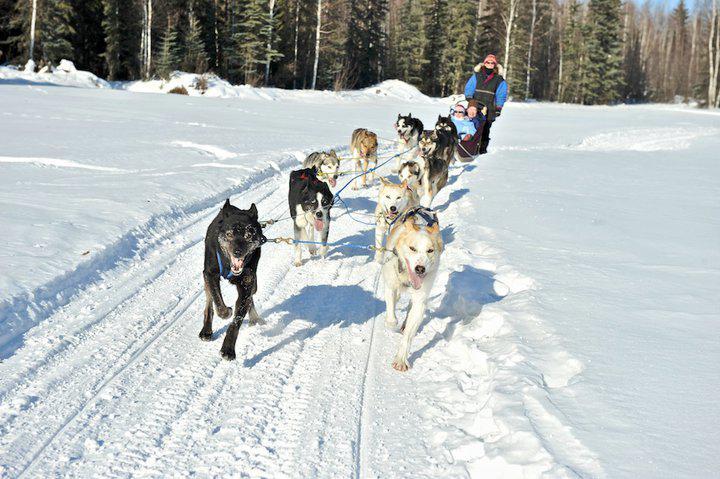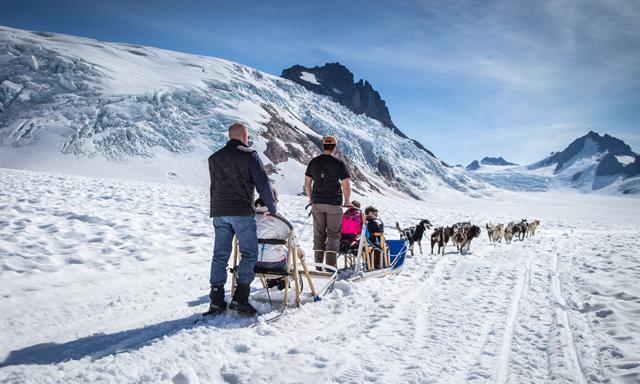The first image is the image on the left, the second image is the image on the right. Considering the images on both sides, is "In at least one image there is a person in blue in the sled and a person in red behind the sled." valid? Answer yes or no. No. The first image is the image on the left, the second image is the image on the right. Analyze the images presented: Is the assertion "Some dogs are resting." valid? Answer yes or no. No. 